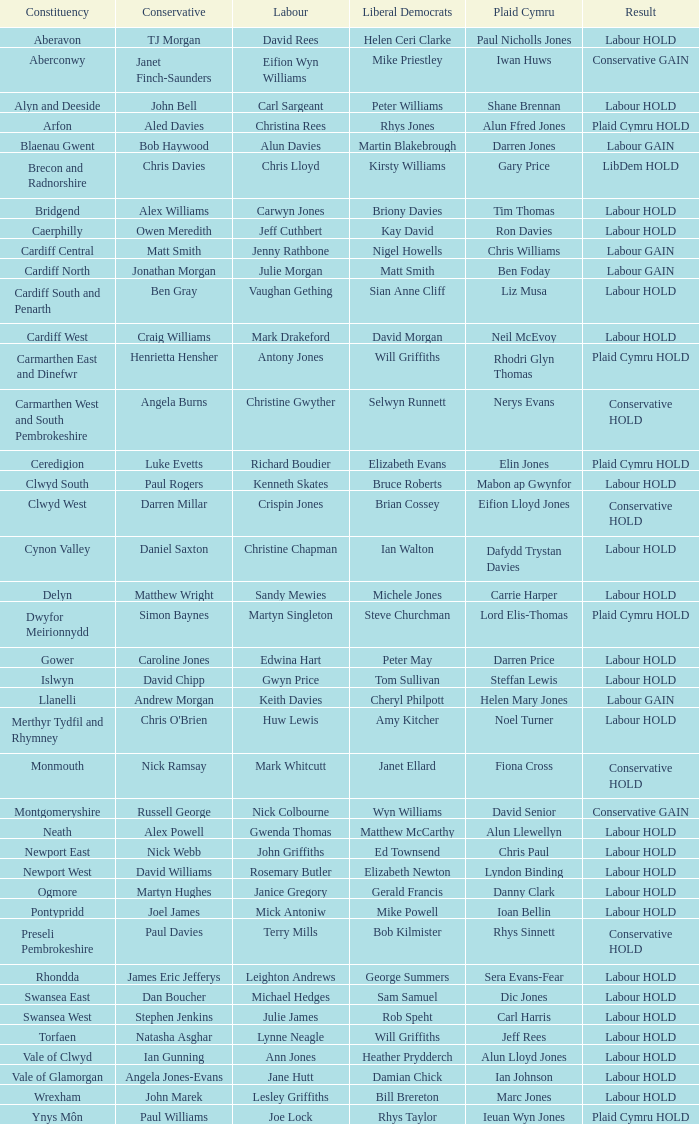I'm looking to parse the entire table for insights. Could you assist me with that? {'header': ['Constituency', 'Conservative', 'Labour', 'Liberal Democrats', 'Plaid Cymru', 'Result'], 'rows': [['Aberavon', 'TJ Morgan', 'David Rees', 'Helen Ceri Clarke', 'Paul Nicholls Jones', 'Labour HOLD'], ['Aberconwy', 'Janet Finch-Saunders', 'Eifion Wyn Williams', 'Mike Priestley', 'Iwan Huws', 'Conservative GAIN'], ['Alyn and Deeside', 'John Bell', 'Carl Sargeant', 'Peter Williams', 'Shane Brennan', 'Labour HOLD'], ['Arfon', 'Aled Davies', 'Christina Rees', 'Rhys Jones', 'Alun Ffred Jones', 'Plaid Cymru HOLD'], ['Blaenau Gwent', 'Bob Haywood', 'Alun Davies', 'Martin Blakebrough', 'Darren Jones', 'Labour GAIN'], ['Brecon and Radnorshire', 'Chris Davies', 'Chris Lloyd', 'Kirsty Williams', 'Gary Price', 'LibDem HOLD'], ['Bridgend', 'Alex Williams', 'Carwyn Jones', 'Briony Davies', 'Tim Thomas', 'Labour HOLD'], ['Caerphilly', 'Owen Meredith', 'Jeff Cuthbert', 'Kay David', 'Ron Davies', 'Labour HOLD'], ['Cardiff Central', 'Matt Smith', 'Jenny Rathbone', 'Nigel Howells', 'Chris Williams', 'Labour GAIN'], ['Cardiff North', 'Jonathan Morgan', 'Julie Morgan', 'Matt Smith', 'Ben Foday', 'Labour GAIN'], ['Cardiff South and Penarth', 'Ben Gray', 'Vaughan Gething', 'Sian Anne Cliff', 'Liz Musa', 'Labour HOLD'], ['Cardiff West', 'Craig Williams', 'Mark Drakeford', 'David Morgan', 'Neil McEvoy', 'Labour HOLD'], ['Carmarthen East and Dinefwr', 'Henrietta Hensher', 'Antony Jones', 'Will Griffiths', 'Rhodri Glyn Thomas', 'Plaid Cymru HOLD'], ['Carmarthen West and South Pembrokeshire', 'Angela Burns', 'Christine Gwyther', 'Selwyn Runnett', 'Nerys Evans', 'Conservative HOLD'], ['Ceredigion', 'Luke Evetts', 'Richard Boudier', 'Elizabeth Evans', 'Elin Jones', 'Plaid Cymru HOLD'], ['Clwyd South', 'Paul Rogers', 'Kenneth Skates', 'Bruce Roberts', 'Mabon ap Gwynfor', 'Labour HOLD'], ['Clwyd West', 'Darren Millar', 'Crispin Jones', 'Brian Cossey', 'Eifion Lloyd Jones', 'Conservative HOLD'], ['Cynon Valley', 'Daniel Saxton', 'Christine Chapman', 'Ian Walton', 'Dafydd Trystan Davies', 'Labour HOLD'], ['Delyn', 'Matthew Wright', 'Sandy Mewies', 'Michele Jones', 'Carrie Harper', 'Labour HOLD'], ['Dwyfor Meirionnydd', 'Simon Baynes', 'Martyn Singleton', 'Steve Churchman', 'Lord Elis-Thomas', 'Plaid Cymru HOLD'], ['Gower', 'Caroline Jones', 'Edwina Hart', 'Peter May', 'Darren Price', 'Labour HOLD'], ['Islwyn', 'David Chipp', 'Gwyn Price', 'Tom Sullivan', 'Steffan Lewis', 'Labour HOLD'], ['Llanelli', 'Andrew Morgan', 'Keith Davies', 'Cheryl Philpott', 'Helen Mary Jones', 'Labour GAIN'], ['Merthyr Tydfil and Rhymney', "Chris O'Brien", 'Huw Lewis', 'Amy Kitcher', 'Noel Turner', 'Labour HOLD'], ['Monmouth', 'Nick Ramsay', 'Mark Whitcutt', 'Janet Ellard', 'Fiona Cross', 'Conservative HOLD'], ['Montgomeryshire', 'Russell George', 'Nick Colbourne', 'Wyn Williams', 'David Senior', 'Conservative GAIN'], ['Neath', 'Alex Powell', 'Gwenda Thomas', 'Matthew McCarthy', 'Alun Llewellyn', 'Labour HOLD'], ['Newport East', 'Nick Webb', 'John Griffiths', 'Ed Townsend', 'Chris Paul', 'Labour HOLD'], ['Newport West', 'David Williams', 'Rosemary Butler', 'Elizabeth Newton', 'Lyndon Binding', 'Labour HOLD'], ['Ogmore', 'Martyn Hughes', 'Janice Gregory', 'Gerald Francis', 'Danny Clark', 'Labour HOLD'], ['Pontypridd', 'Joel James', 'Mick Antoniw', 'Mike Powell', 'Ioan Bellin', 'Labour HOLD'], ['Preseli Pembrokeshire', 'Paul Davies', 'Terry Mills', 'Bob Kilmister', 'Rhys Sinnett', 'Conservative HOLD'], ['Rhondda', 'James Eric Jefferys', 'Leighton Andrews', 'George Summers', 'Sera Evans-Fear', 'Labour HOLD'], ['Swansea East', 'Dan Boucher', 'Michael Hedges', 'Sam Samuel', 'Dic Jones', 'Labour HOLD'], ['Swansea West', 'Stephen Jenkins', 'Julie James', 'Rob Speht', 'Carl Harris', 'Labour HOLD'], ['Torfaen', 'Natasha Asghar', 'Lynne Neagle', 'Will Griffiths', 'Jeff Rees', 'Labour HOLD'], ['Vale of Clwyd', 'Ian Gunning', 'Ann Jones', 'Heather Prydderch', 'Alun Lloyd Jones', 'Labour HOLD'], ['Vale of Glamorgan', 'Angela Jones-Evans', 'Jane Hutt', 'Damian Chick', 'Ian Johnson', 'Labour HOLD'], ['Wrexham', 'John Marek', 'Lesley Griffiths', 'Bill Brereton', 'Marc Jones', 'Labour HOLD'], ['Ynys Môn', 'Paul Williams', 'Joe Lock', 'Rhys Taylor', 'Ieuan Wyn Jones', 'Plaid Cymru HOLD']]} What is the constituency of the conservative darren millar? Clwyd West. 